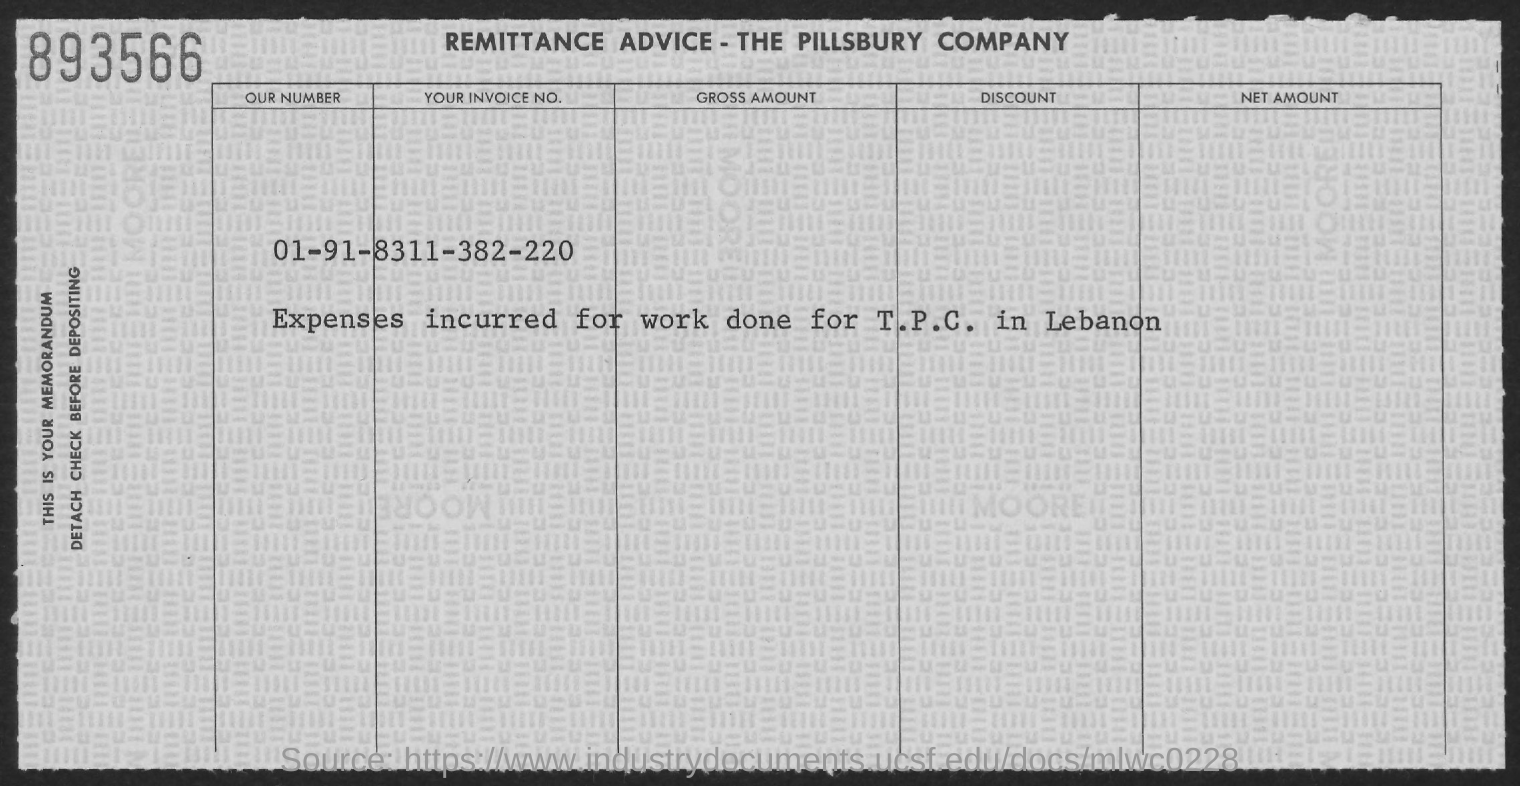Expenses incurred for work done for whom?
Give a very brief answer. T.P.C. in Lebanon. What is the Tour Invoice No.?
Offer a terse response. 8311-382-220. 